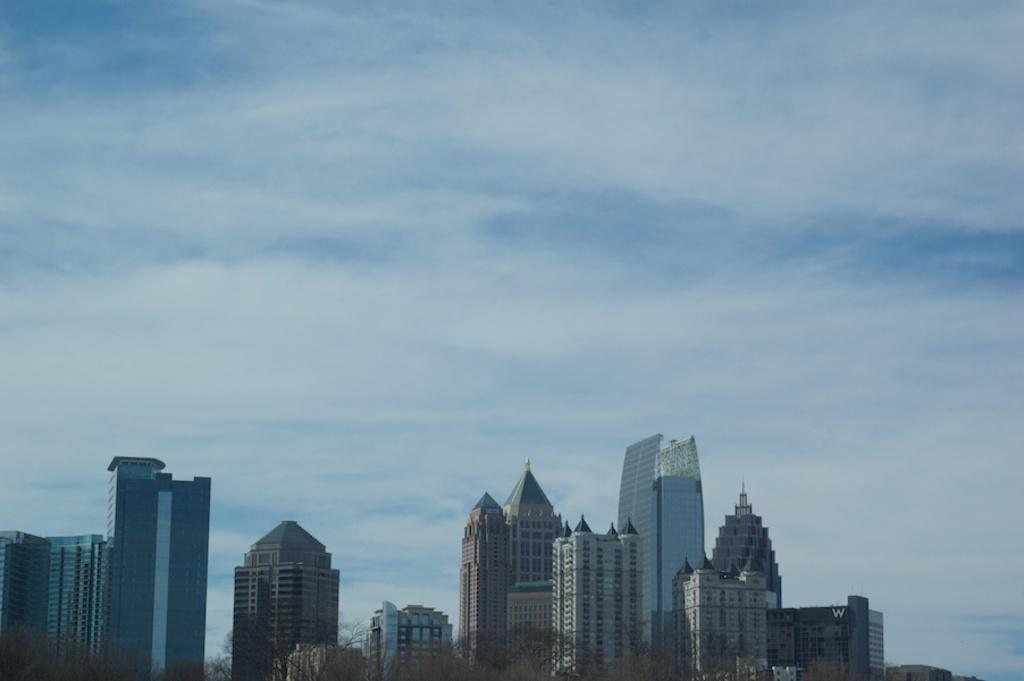How would you summarize this image in a sentence or two? In this image I can see there are buildings and trees. And at the top there is a sky. 